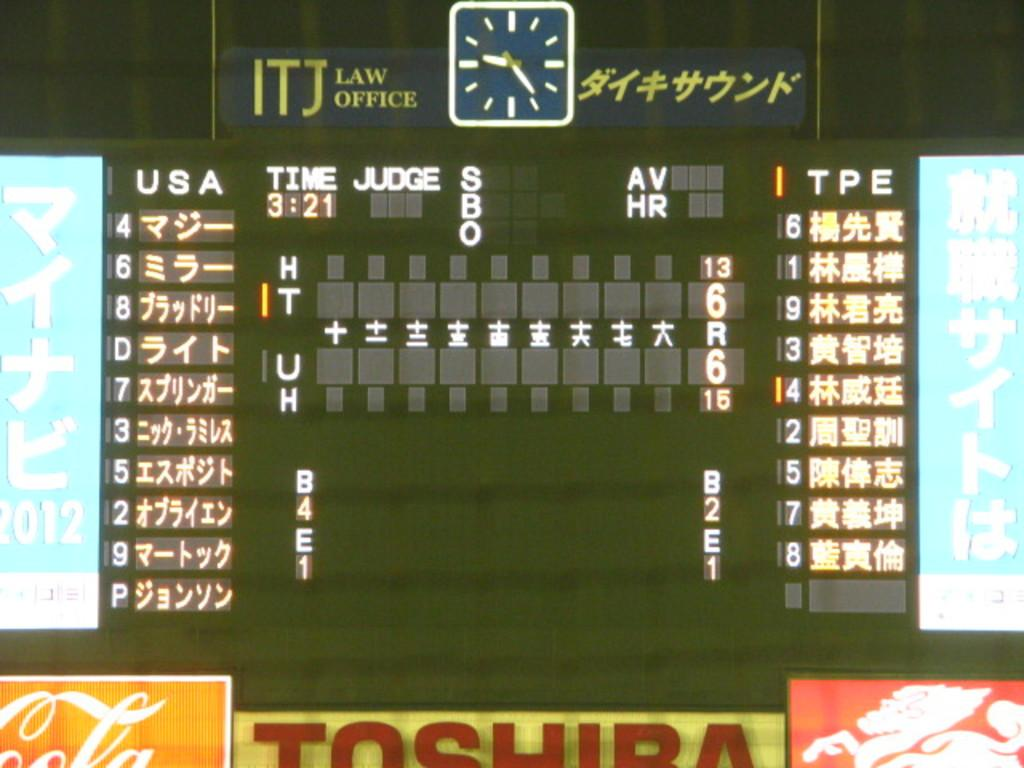<image>
Provide a brief description of the given image. Number 4 is leading off for team USA. 